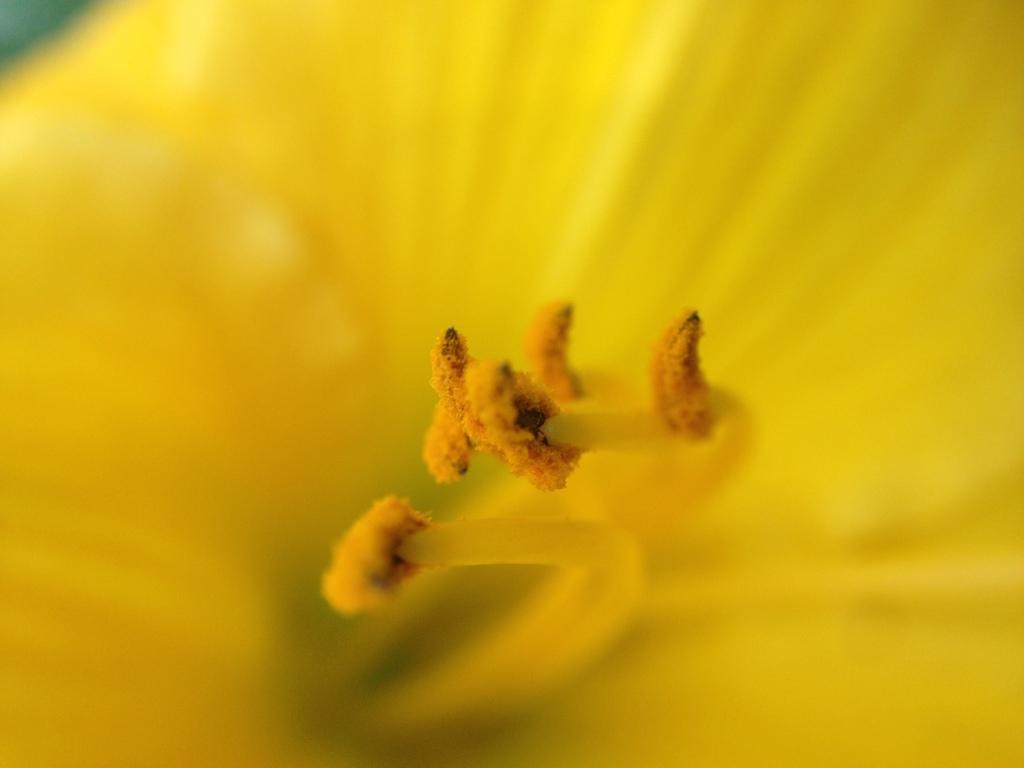Please provide a concise description of this image. In this image we can see a yellow flower and buds. 